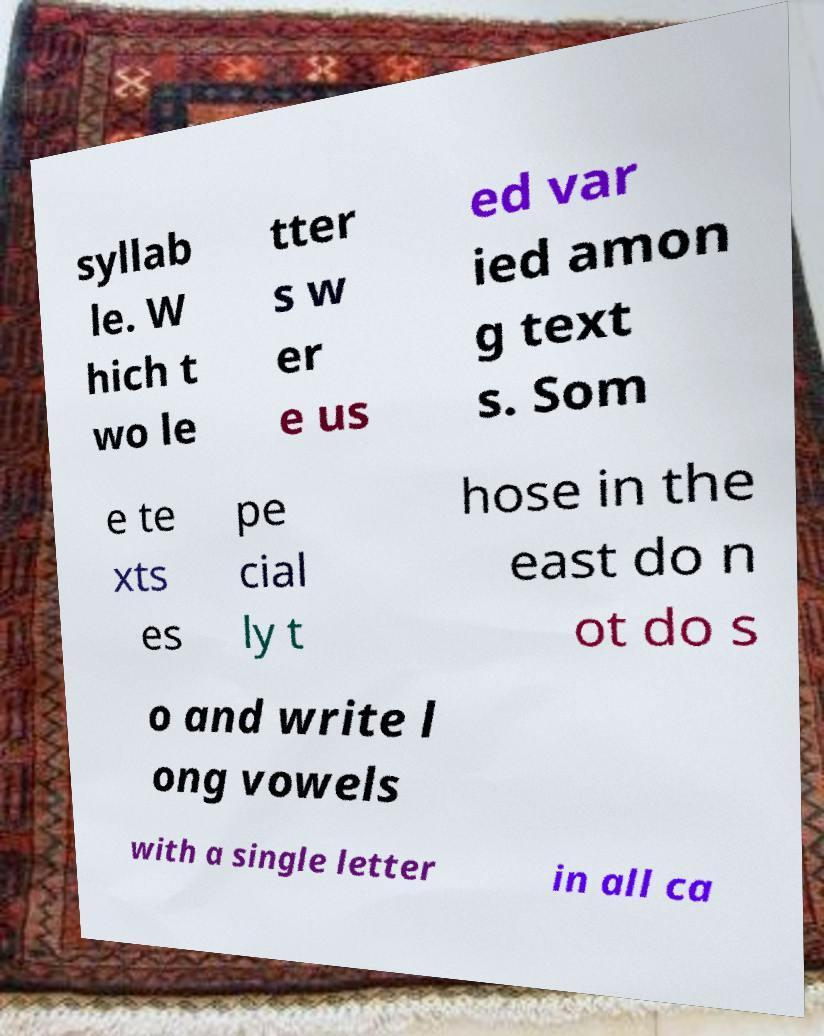Could you extract and type out the text from this image? syllab le. W hich t wo le tter s w er e us ed var ied amon g text s. Som e te xts es pe cial ly t hose in the east do n ot do s o and write l ong vowels with a single letter in all ca 